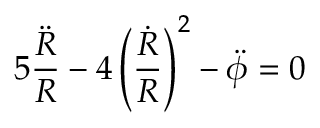<formula> <loc_0><loc_0><loc_500><loc_500>5 \frac { \ddot { R } } { R } - 4 \left ( \frac { \dot { R } } { R } \right ) ^ { 2 } - \ddot { \phi } = 0</formula> 